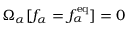Convert formula to latex. <formula><loc_0><loc_0><loc_500><loc_500>\Omega _ { \alpha } [ f _ { \alpha } = f _ { \alpha } ^ { e q } ] = 0</formula> 